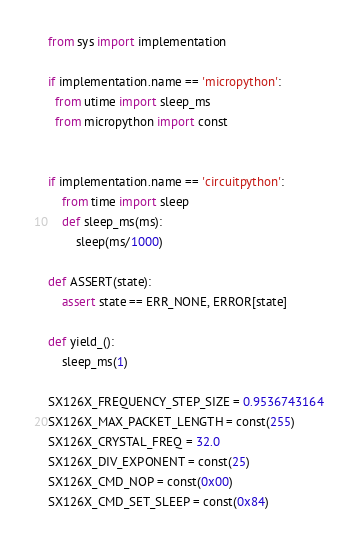Convert code to text. <code><loc_0><loc_0><loc_500><loc_500><_Python_>from sys import implementation

if implementation.name == 'micropython':
  from utime import sleep_ms
  from micropython import const


if implementation.name == 'circuitpython':
    from time import sleep
    def sleep_ms(ms):
        sleep(ms/1000)

def ASSERT(state):
    assert state == ERR_NONE, ERROR[state]

def yield_():
    sleep_ms(1)

SX126X_FREQUENCY_STEP_SIZE = 0.9536743164
SX126X_MAX_PACKET_LENGTH = const(255)
SX126X_CRYSTAL_FREQ = 32.0
SX126X_DIV_EXPONENT = const(25)
SX126X_CMD_NOP = const(0x00)
SX126X_CMD_SET_SLEEP = const(0x84)</code> 